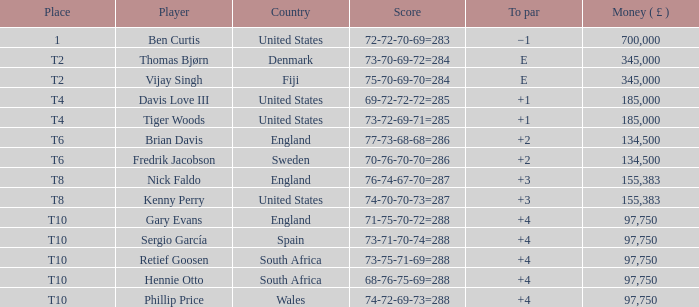What is the To Par of Fredrik Jacobson? 2.0. 